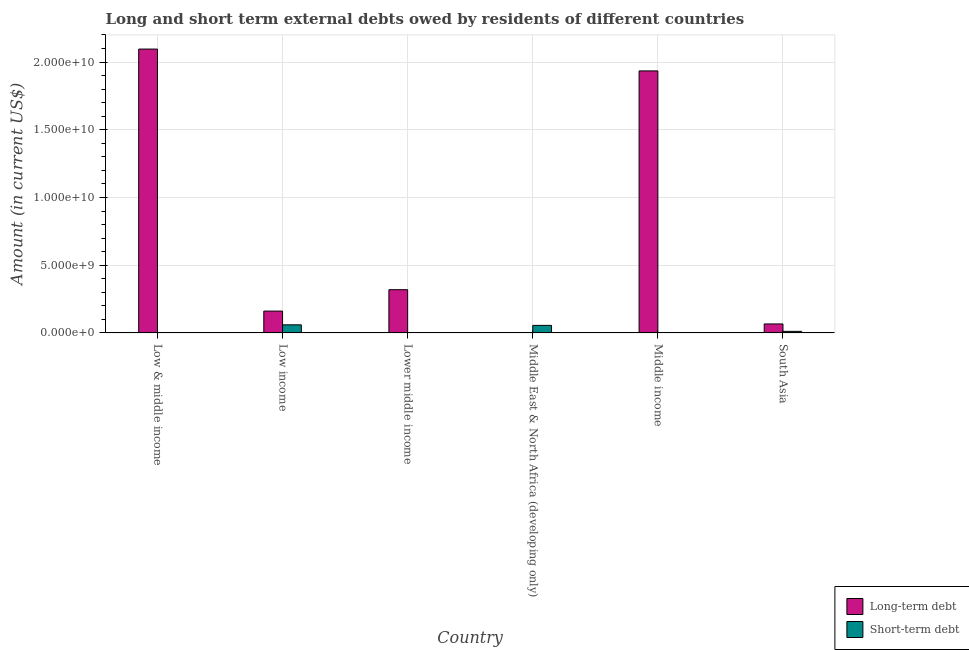Are the number of bars on each tick of the X-axis equal?
Ensure brevity in your answer.  No. How many bars are there on the 4th tick from the right?
Your answer should be compact. 1. What is the label of the 2nd group of bars from the left?
Give a very brief answer. Low income. Across all countries, what is the maximum short-term debts owed by residents?
Make the answer very short. 5.99e+08. Across all countries, what is the minimum long-term debts owed by residents?
Offer a terse response. 0. What is the total long-term debts owed by residents in the graph?
Offer a terse response. 4.58e+1. What is the difference between the short-term debts owed by residents in Middle East & North Africa (developing only) and that in South Asia?
Your response must be concise. 4.41e+08. What is the difference between the short-term debts owed by residents in Middle income and the long-term debts owed by residents in Middle East & North Africa (developing only)?
Your answer should be very brief. 0. What is the average long-term debts owed by residents per country?
Your answer should be compact. 7.63e+09. What is the difference between the long-term debts owed by residents and short-term debts owed by residents in Low income?
Your answer should be very brief. 1.01e+09. In how many countries, is the long-term debts owed by residents greater than 19000000000 US$?
Ensure brevity in your answer.  2. What is the ratio of the short-term debts owed by residents in Low income to that in South Asia?
Your response must be concise. 5.11. Is the long-term debts owed by residents in Low & middle income less than that in South Asia?
Ensure brevity in your answer.  No. Is the difference between the long-term debts owed by residents in Low income and South Asia greater than the difference between the short-term debts owed by residents in Low income and South Asia?
Your answer should be very brief. Yes. What is the difference between the highest and the second highest short-term debts owed by residents?
Your answer should be compact. 4.09e+07. What is the difference between the highest and the lowest short-term debts owed by residents?
Give a very brief answer. 5.99e+08. Is the sum of the long-term debts owed by residents in Low income and Lower middle income greater than the maximum short-term debts owed by residents across all countries?
Give a very brief answer. Yes. How many bars are there?
Ensure brevity in your answer.  8. How many legend labels are there?
Keep it short and to the point. 2. How are the legend labels stacked?
Provide a succinct answer. Vertical. What is the title of the graph?
Offer a terse response. Long and short term external debts owed by residents of different countries. What is the Amount (in current US$) in Long-term debt in Low & middle income?
Provide a succinct answer. 2.10e+1. What is the Amount (in current US$) of Short-term debt in Low & middle income?
Offer a terse response. 0. What is the Amount (in current US$) of Long-term debt in Low income?
Make the answer very short. 1.61e+09. What is the Amount (in current US$) of Short-term debt in Low income?
Your response must be concise. 5.99e+08. What is the Amount (in current US$) in Long-term debt in Lower middle income?
Your response must be concise. 3.19e+09. What is the Amount (in current US$) in Short-term debt in Lower middle income?
Offer a terse response. 0. What is the Amount (in current US$) in Long-term debt in Middle East & North Africa (developing only)?
Provide a short and direct response. 0. What is the Amount (in current US$) in Short-term debt in Middle East & North Africa (developing only)?
Make the answer very short. 5.58e+08. What is the Amount (in current US$) in Long-term debt in Middle income?
Offer a very short reply. 1.93e+1. What is the Amount (in current US$) of Long-term debt in South Asia?
Your response must be concise. 6.64e+08. What is the Amount (in current US$) of Short-term debt in South Asia?
Your answer should be very brief. 1.17e+08. Across all countries, what is the maximum Amount (in current US$) in Long-term debt?
Your answer should be very brief. 2.10e+1. Across all countries, what is the maximum Amount (in current US$) of Short-term debt?
Provide a short and direct response. 5.99e+08. Across all countries, what is the minimum Amount (in current US$) of Short-term debt?
Your response must be concise. 0. What is the total Amount (in current US$) of Long-term debt in the graph?
Your answer should be very brief. 4.58e+1. What is the total Amount (in current US$) in Short-term debt in the graph?
Provide a short and direct response. 1.27e+09. What is the difference between the Amount (in current US$) in Long-term debt in Low & middle income and that in Low income?
Make the answer very short. 1.93e+1. What is the difference between the Amount (in current US$) in Long-term debt in Low & middle income and that in Lower middle income?
Your answer should be very brief. 1.78e+1. What is the difference between the Amount (in current US$) in Long-term debt in Low & middle income and that in Middle income?
Provide a short and direct response. 1.61e+09. What is the difference between the Amount (in current US$) of Long-term debt in Low & middle income and that in South Asia?
Give a very brief answer. 2.03e+1. What is the difference between the Amount (in current US$) in Long-term debt in Low income and that in Lower middle income?
Ensure brevity in your answer.  -1.58e+09. What is the difference between the Amount (in current US$) in Short-term debt in Low income and that in Middle East & North Africa (developing only)?
Keep it short and to the point. 4.09e+07. What is the difference between the Amount (in current US$) of Long-term debt in Low income and that in Middle income?
Make the answer very short. -1.77e+1. What is the difference between the Amount (in current US$) of Long-term debt in Low income and that in South Asia?
Make the answer very short. 9.49e+08. What is the difference between the Amount (in current US$) of Short-term debt in Low income and that in South Asia?
Offer a very short reply. 4.82e+08. What is the difference between the Amount (in current US$) in Long-term debt in Lower middle income and that in Middle income?
Provide a succinct answer. -1.62e+1. What is the difference between the Amount (in current US$) in Long-term debt in Lower middle income and that in South Asia?
Your response must be concise. 2.53e+09. What is the difference between the Amount (in current US$) in Short-term debt in Middle East & North Africa (developing only) and that in South Asia?
Offer a very short reply. 4.41e+08. What is the difference between the Amount (in current US$) in Long-term debt in Middle income and that in South Asia?
Make the answer very short. 1.87e+1. What is the difference between the Amount (in current US$) of Long-term debt in Low & middle income and the Amount (in current US$) of Short-term debt in Low income?
Ensure brevity in your answer.  2.04e+1. What is the difference between the Amount (in current US$) in Long-term debt in Low & middle income and the Amount (in current US$) in Short-term debt in Middle East & North Africa (developing only)?
Your answer should be very brief. 2.04e+1. What is the difference between the Amount (in current US$) of Long-term debt in Low & middle income and the Amount (in current US$) of Short-term debt in South Asia?
Your answer should be compact. 2.08e+1. What is the difference between the Amount (in current US$) in Long-term debt in Low income and the Amount (in current US$) in Short-term debt in Middle East & North Africa (developing only)?
Offer a terse response. 1.06e+09. What is the difference between the Amount (in current US$) in Long-term debt in Low income and the Amount (in current US$) in Short-term debt in South Asia?
Your answer should be compact. 1.50e+09. What is the difference between the Amount (in current US$) in Long-term debt in Lower middle income and the Amount (in current US$) in Short-term debt in Middle East & North Africa (developing only)?
Your answer should be very brief. 2.64e+09. What is the difference between the Amount (in current US$) of Long-term debt in Lower middle income and the Amount (in current US$) of Short-term debt in South Asia?
Provide a short and direct response. 3.08e+09. What is the difference between the Amount (in current US$) of Long-term debt in Middle income and the Amount (in current US$) of Short-term debt in South Asia?
Make the answer very short. 1.92e+1. What is the average Amount (in current US$) in Long-term debt per country?
Provide a short and direct response. 7.63e+09. What is the average Amount (in current US$) of Short-term debt per country?
Offer a very short reply. 2.12e+08. What is the difference between the Amount (in current US$) in Long-term debt and Amount (in current US$) in Short-term debt in Low income?
Your answer should be very brief. 1.01e+09. What is the difference between the Amount (in current US$) in Long-term debt and Amount (in current US$) in Short-term debt in South Asia?
Your answer should be very brief. 5.47e+08. What is the ratio of the Amount (in current US$) of Long-term debt in Low & middle income to that in Low income?
Your answer should be compact. 12.99. What is the ratio of the Amount (in current US$) of Long-term debt in Low & middle income to that in Lower middle income?
Make the answer very short. 6.56. What is the ratio of the Amount (in current US$) of Long-term debt in Low & middle income to that in Middle income?
Give a very brief answer. 1.08. What is the ratio of the Amount (in current US$) of Long-term debt in Low & middle income to that in South Asia?
Offer a terse response. 31.58. What is the ratio of the Amount (in current US$) of Long-term debt in Low income to that in Lower middle income?
Offer a very short reply. 0.51. What is the ratio of the Amount (in current US$) in Short-term debt in Low income to that in Middle East & North Africa (developing only)?
Your response must be concise. 1.07. What is the ratio of the Amount (in current US$) of Long-term debt in Low income to that in Middle income?
Provide a succinct answer. 0.08. What is the ratio of the Amount (in current US$) of Long-term debt in Low income to that in South Asia?
Offer a very short reply. 2.43. What is the ratio of the Amount (in current US$) in Short-term debt in Low income to that in South Asia?
Your answer should be compact. 5.11. What is the ratio of the Amount (in current US$) in Long-term debt in Lower middle income to that in Middle income?
Your answer should be compact. 0.17. What is the ratio of the Amount (in current US$) in Long-term debt in Lower middle income to that in South Asia?
Ensure brevity in your answer.  4.81. What is the ratio of the Amount (in current US$) in Short-term debt in Middle East & North Africa (developing only) to that in South Asia?
Your answer should be compact. 4.76. What is the ratio of the Amount (in current US$) of Long-term debt in Middle income to that in South Asia?
Offer a very short reply. 29.15. What is the difference between the highest and the second highest Amount (in current US$) of Long-term debt?
Provide a succinct answer. 1.61e+09. What is the difference between the highest and the second highest Amount (in current US$) of Short-term debt?
Offer a very short reply. 4.09e+07. What is the difference between the highest and the lowest Amount (in current US$) of Long-term debt?
Keep it short and to the point. 2.10e+1. What is the difference between the highest and the lowest Amount (in current US$) of Short-term debt?
Offer a terse response. 5.99e+08. 